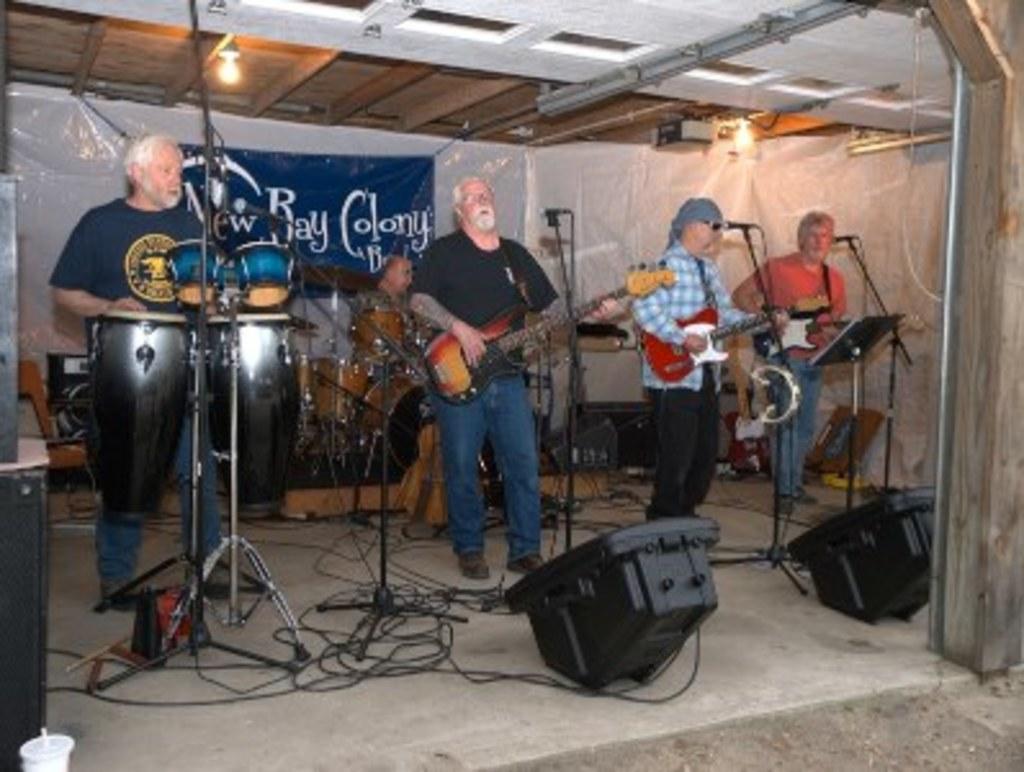How would you summarize this image in a sentence or two? In this image we can see five men. Here we can see three men standing on the floor and they are playing the guitar. Here we can see a man singing on a microphone. Here we can see a man on the left side is playing the conga musical instrument. Here we can see a man playing the snare drum musical instrument. In the background, we can see the banner of the music band. 